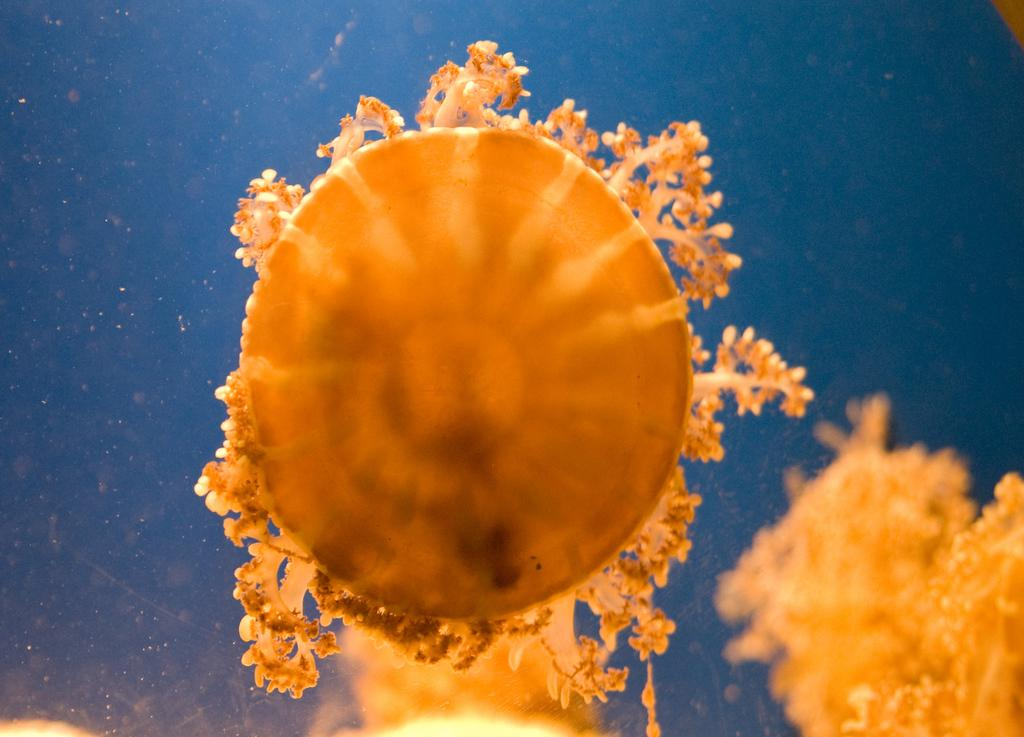What is visible in the image? Water is visible in the image. What can be found in the water? There are underwater animals in the water. How much debt is being paid off by the underwater animals in the image? There is no mention of debt or any financial transactions in the image, as it features underwater animals in water. 